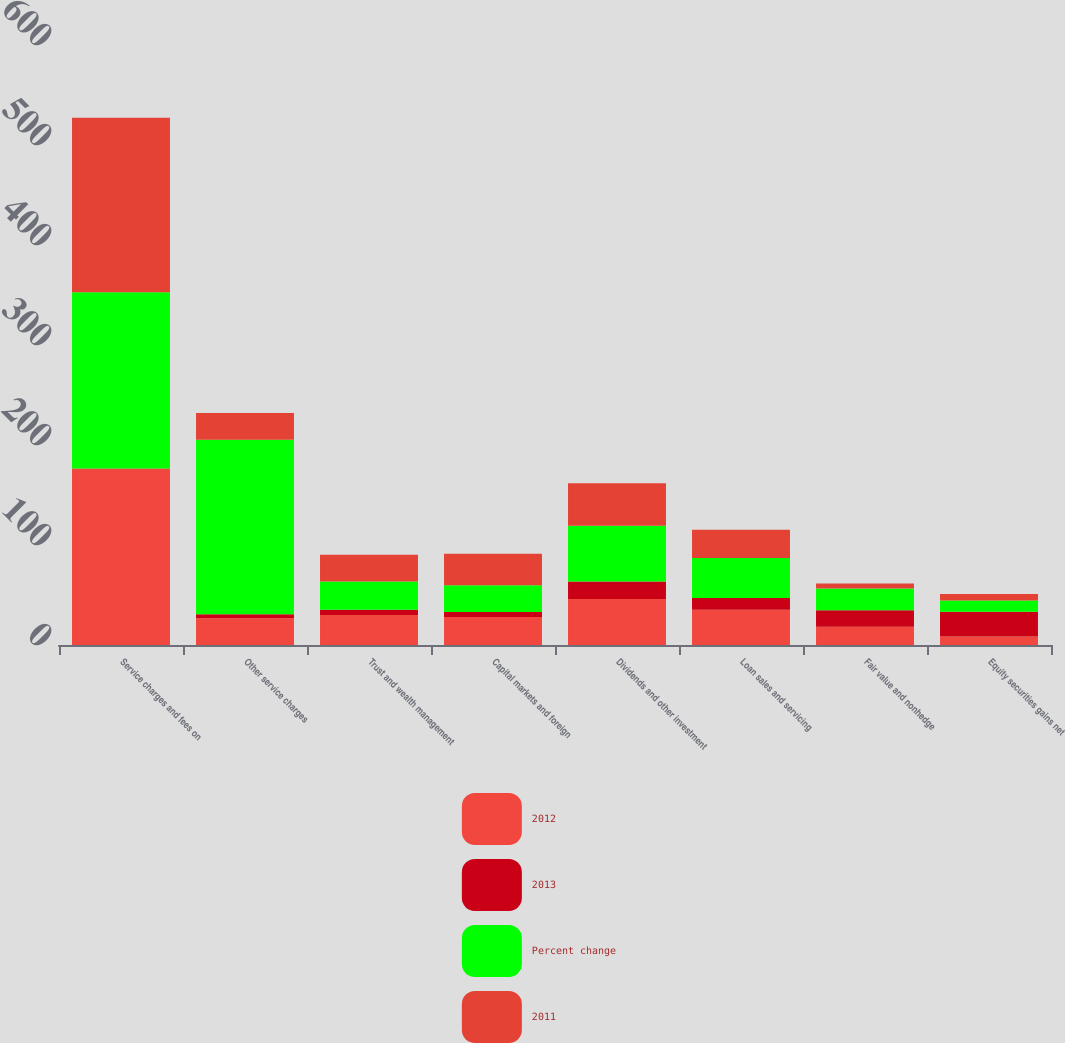Convert chart. <chart><loc_0><loc_0><loc_500><loc_500><stacked_bar_chart><ecel><fcel>Service charges and fees on<fcel>Other service charges<fcel>Trust and wealth management<fcel>Capital markets and foreign<fcel>Dividends and other investment<fcel>Loan sales and servicing<fcel>Fair value and nonhedge<fcel>Equity securities gains net<nl><fcel>2012<fcel>176.3<fcel>26.75<fcel>29.9<fcel>28.1<fcel>46.1<fcel>35.3<fcel>18.2<fcel>8.5<nl><fcel>2013<fcel>0.1<fcel>4.1<fcel>5.3<fcel>4.9<fcel>17.4<fcel>11.8<fcel>16.5<fcel>24.8<nl><fcel>Percent change<fcel>176.4<fcel>174.4<fcel>28.4<fcel>26.8<fcel>55.8<fcel>40<fcel>21.8<fcel>11.3<nl><fcel>2011<fcel>174.4<fcel>26.75<fcel>26.7<fcel>31.4<fcel>42.4<fcel>28.1<fcel>5<fcel>6.5<nl></chart> 